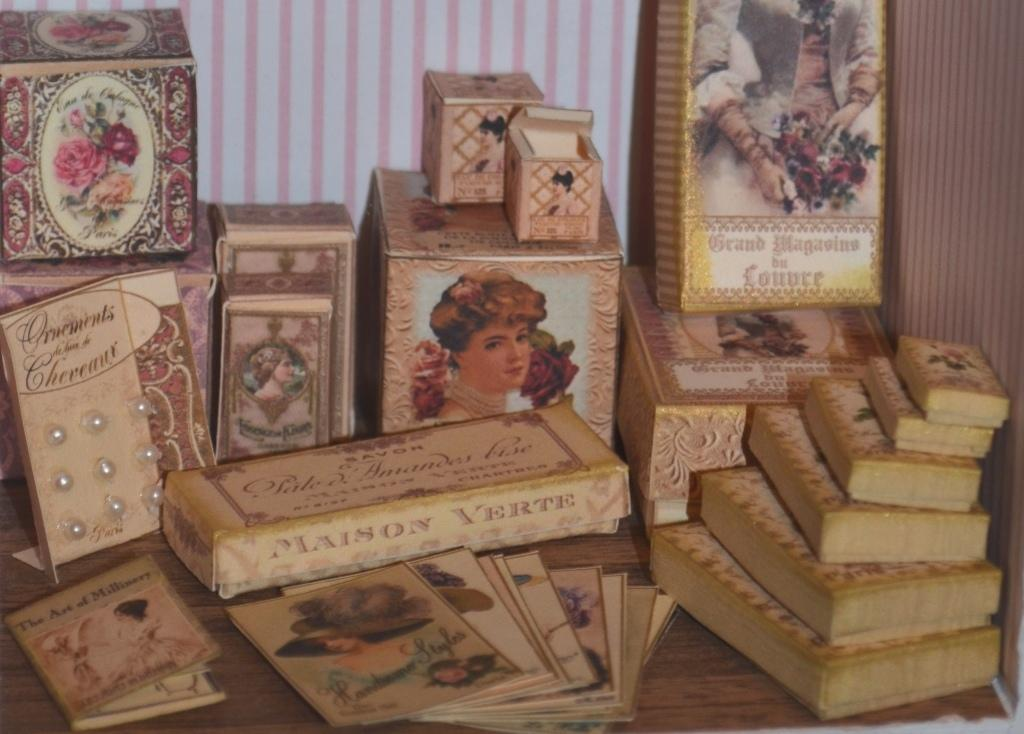<image>
Give a short and clear explanation of the subsequent image. A Maison Verte book sits among a stack of antique books 